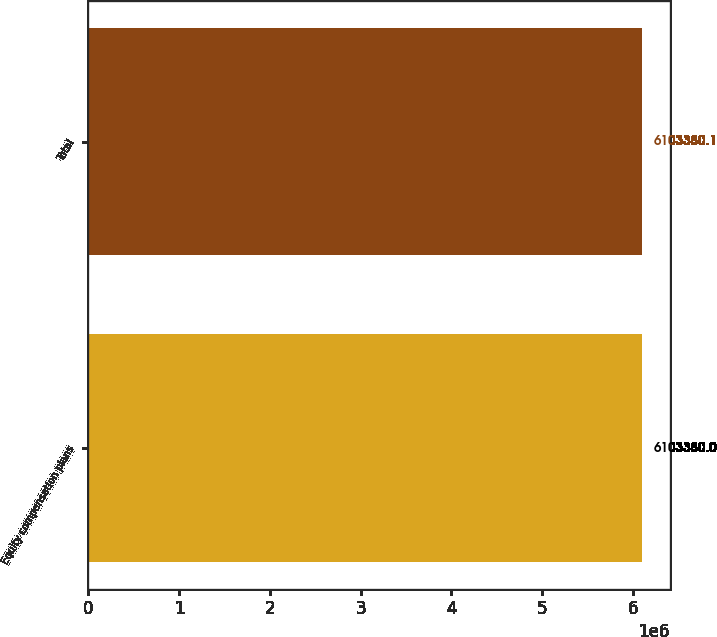Convert chart to OTSL. <chart><loc_0><loc_0><loc_500><loc_500><bar_chart><fcel>Equity compensation plans<fcel>Total<nl><fcel>6.10338e+06<fcel>6.10338e+06<nl></chart> 